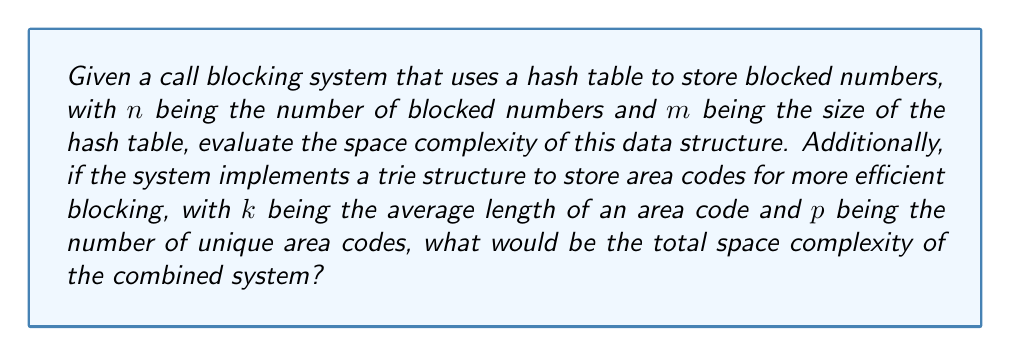Solve this math problem. To evaluate the space complexity, we need to consider both the hash table and the trie structure:

1. Hash Table:
   - The hash table stores $n$ blocked numbers.
   - The size of the hash table is $m$.
   - Space complexity of a hash table is $O(m)$, as we need to allocate space for all $m$ slots, regardless of how many are filled.

2. Trie Structure:
   - The trie stores $p$ unique area codes.
   - Each area code has an average length of $k$.
   - In a trie, each node typically stores a character and pointers to its children.
   - The space complexity of a trie is $O(k \cdot p)$, as we have $p$ paths, each of average length $k$.

3. Combined System:
   - The total space complexity is the sum of the individual complexities.
   - Hash Table + Trie = $O(m) + O(k \cdot p)$
   - This can be written as $O(m + k \cdot p)$

It's important to note that in practice, $m$ is often chosen to be proportional to $n$ (e.g., $m = 2n$) to balance between space usage and collision probability. In such cases, we could simplify the hash table complexity to $O(n)$.
Answer: The total space complexity of the combined system is $O(m + k \cdot p)$, where $m$ is the size of the hash table, $k$ is the average length of an area code, and $p$ is the number of unique area codes. 